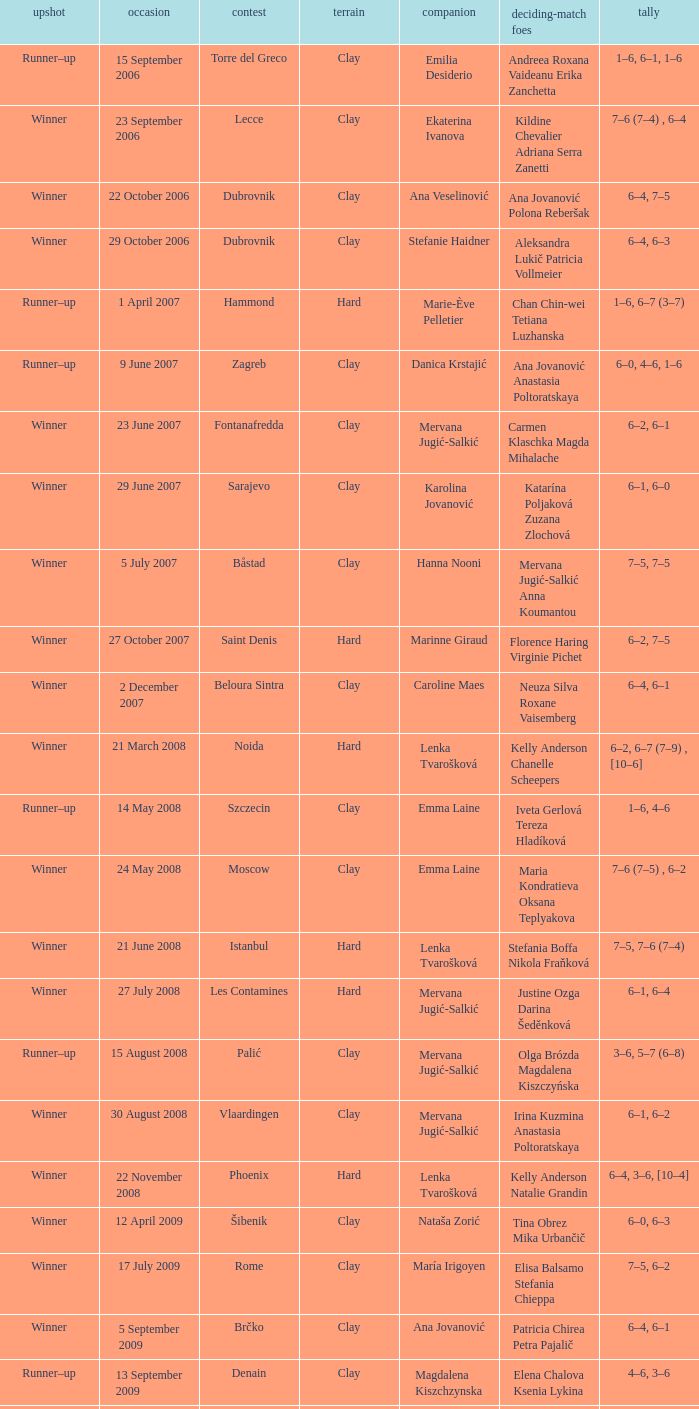Who were the opponents in the final at Noida? Kelly Anderson Chanelle Scheepers. 